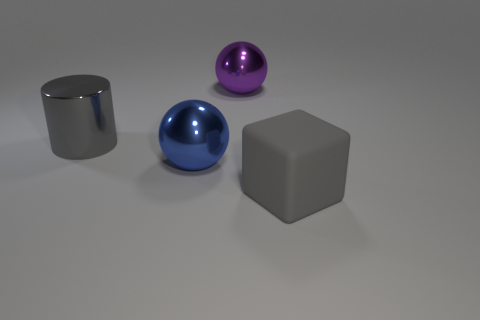Add 2 gray objects. How many objects exist? 6 Subtract all cylinders. How many objects are left? 3 Subtract all big brown rubber cubes. Subtract all gray metal things. How many objects are left? 3 Add 2 blue metallic spheres. How many blue metallic spheres are left? 3 Add 4 purple balls. How many purple balls exist? 5 Subtract 0 blue blocks. How many objects are left? 4 